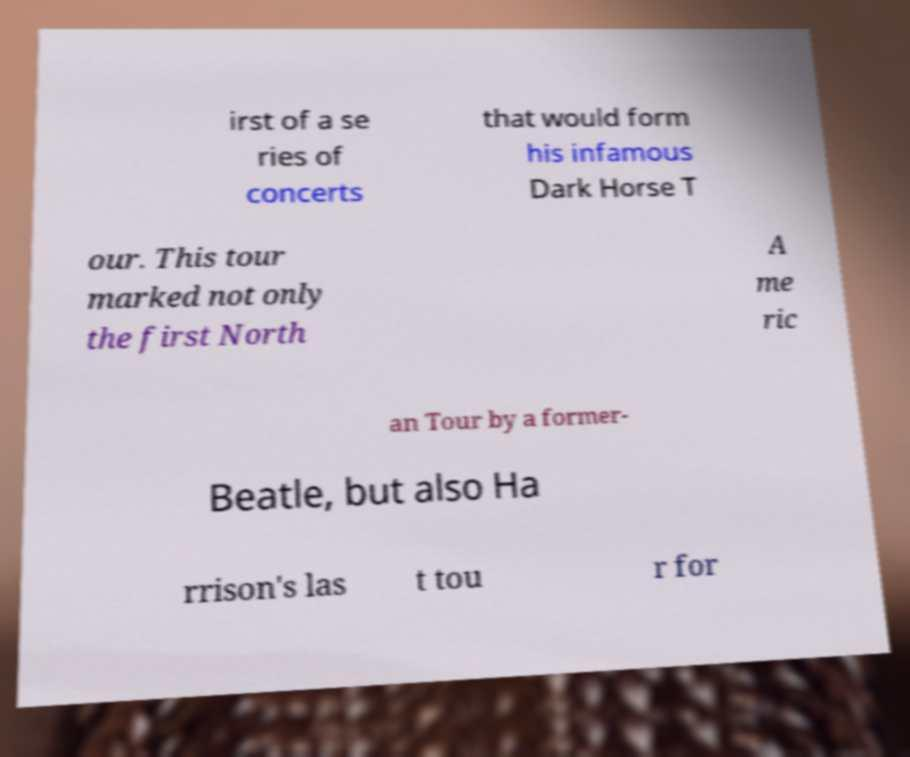What messages or text are displayed in this image? I need them in a readable, typed format. irst of a se ries of concerts that would form his infamous Dark Horse T our. This tour marked not only the first North A me ric an Tour by a former- Beatle, but also Ha rrison's las t tou r for 